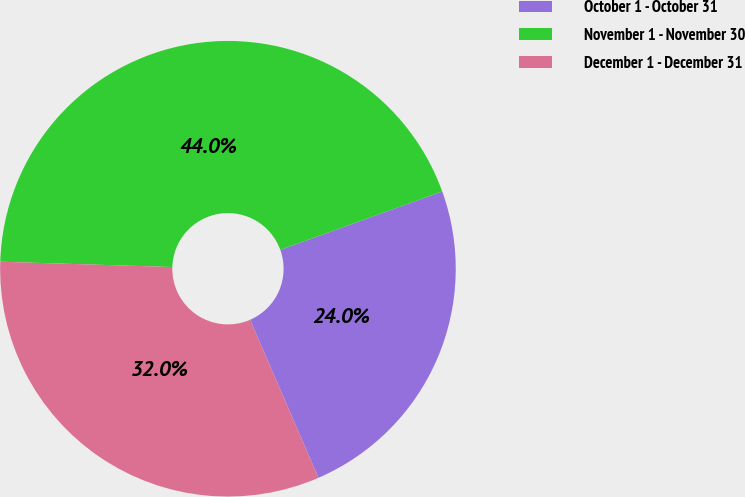Convert chart to OTSL. <chart><loc_0><loc_0><loc_500><loc_500><pie_chart><fcel>October 1 - October 31<fcel>November 1 - November 30<fcel>December 1 - December 31<nl><fcel>24.0%<fcel>44.0%<fcel>32.0%<nl></chart> 